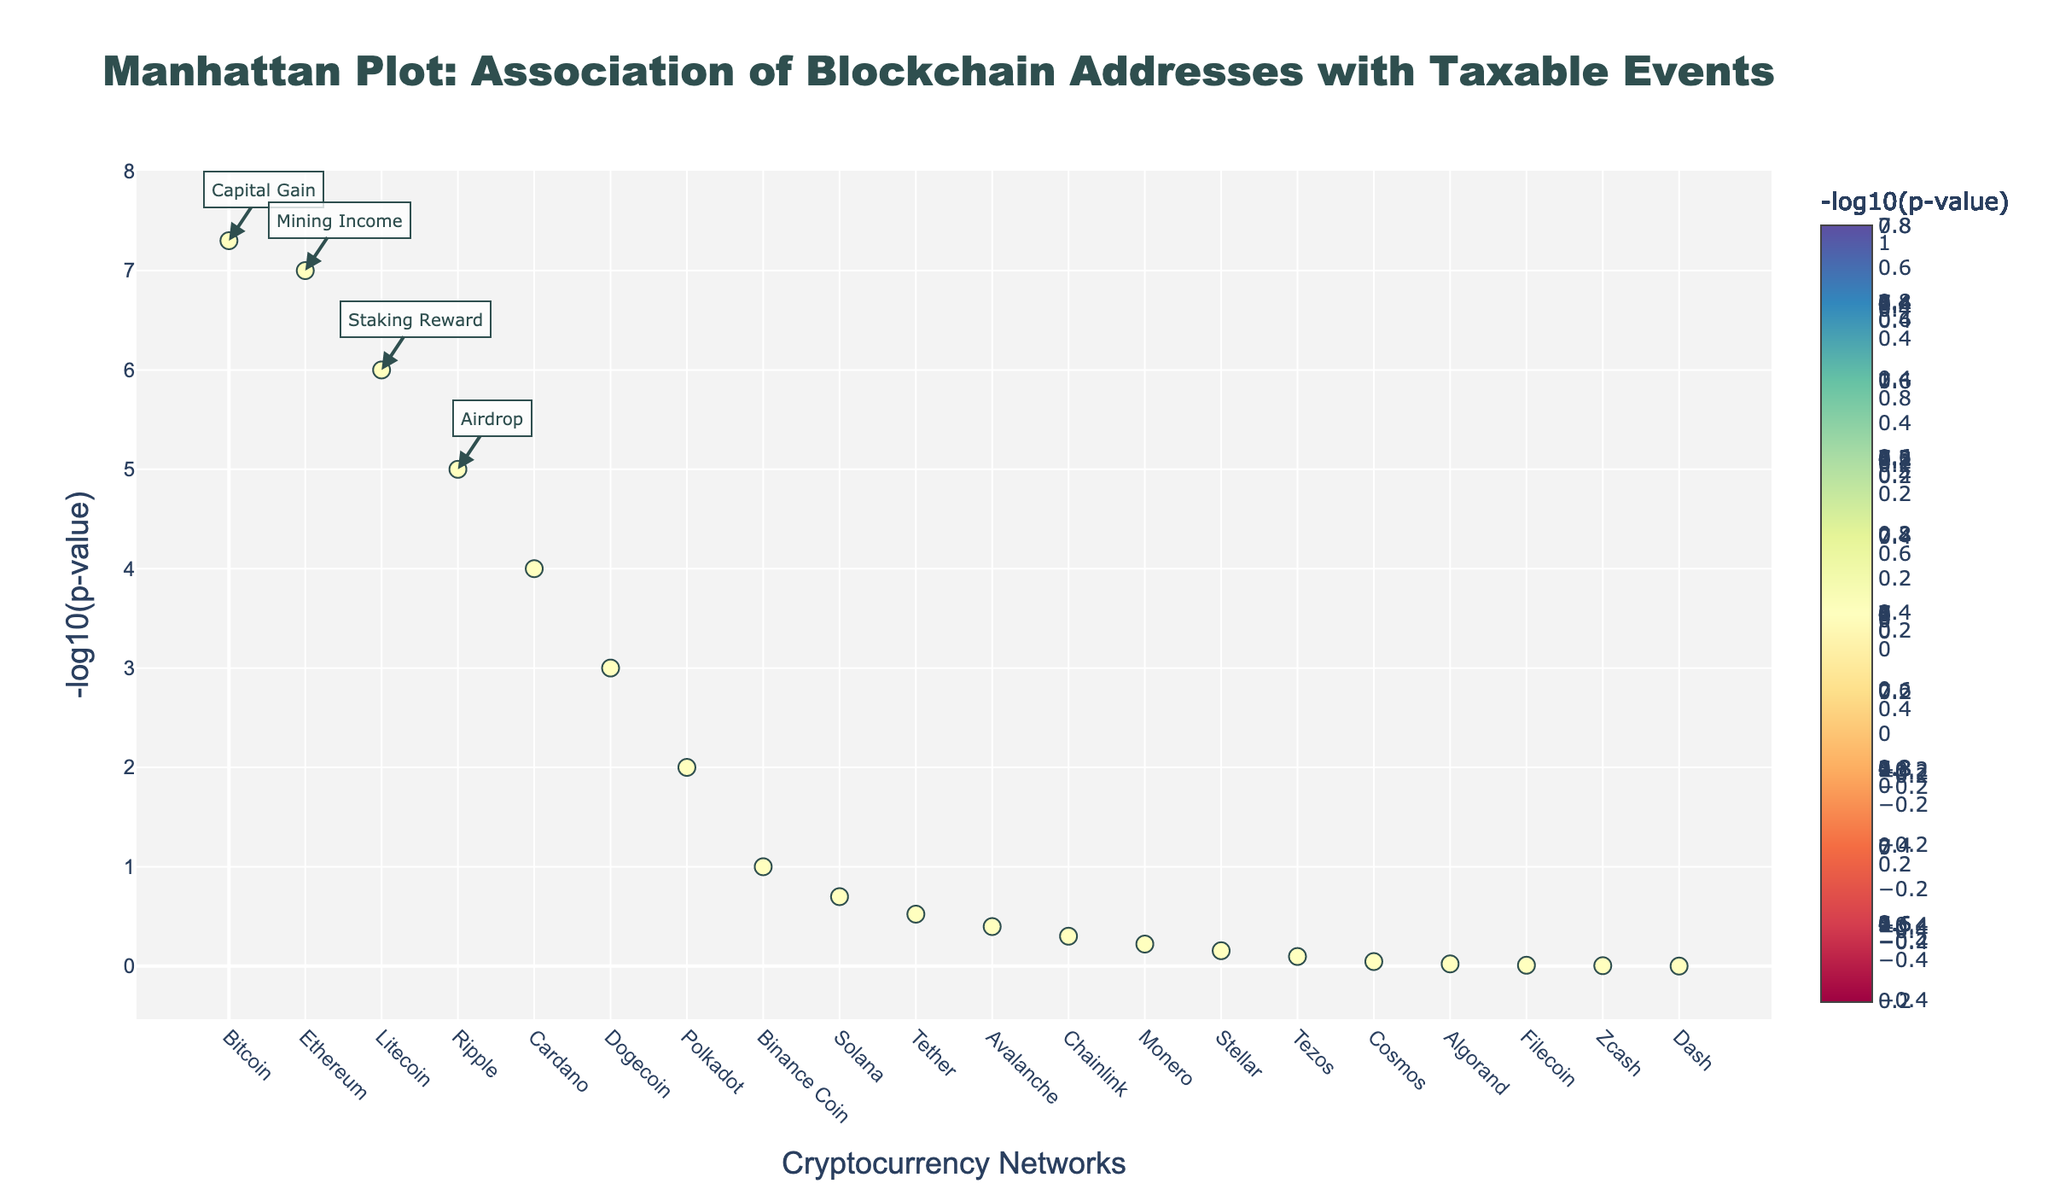What is the title of the plot? The title of the plot is prominently displayed at the top of the figure. It reads 'Manhattan Plot: Association of Blockchain Addresses with Taxable Events'.
Answer: Manhattan Plot: Association of Blockchain Addresses with Taxable Events Which cryptocurrency has the smallest p-value, and what taxable event does it correspond to? By observing the figure, the cryptocurrency with the smallest p-value is Bitcoin. It is located at the far left with the tallest bar, and the hover information indicates the corresponding taxable event is 'Capital Gain'.
Answer: Bitcoin, Capital Gain How many cryptocurrencies have a -log10(p-value) greater than 4? To determine this, we count the number of points above the y-value of 4 on the plot. Bitcoin and Ethereum surpass this threshold.
Answer: 2 What is the -log10(p-value) for Ripple? You can find this by locating Ripple on the x-axis and reading the corresponding y-value. The -log10(p-value) for Ripple is around 5.
Answer: 5 Compare the -log10(p-value) of Ethereum and Litecoin. Which is higher? Locate Ethereum and Litecoin on the x-axis. Ethereum’s -log10(p-value) is around 7, and Litecoin’s is around 6.
Answer: Ethereum Which taxable events have p-values between 0.0001 and 0.001? Find points that fall within the y-range (-log10(p-value)) of 3 to 4. These correspond to Litecoin and Cardano, with the taxable events 'Staking Reward' and 'NFT Sale' respectively.
Answer: Staking Reward, NFT Sale Which cryptocurrency has the lowest -log10(p-value), and what taxable event does it correspond to? The cryptocurrency with the lowest -log10(p-value) can be identified by finding the shortest bar. Dash, which is on the far right, has the lowest -log10(p-value), and the corresponding taxable event is 'Masternode Reward'.
Answer: Dash, Masternode Reward What is the approximate -log10(p-value) for Dogecoin, and what is the associated taxable event? Locate Dogecoin on the x-axis and read the y-value. Dogecoin appears to have a -log10(p-value) around 3, corresponding to 'Margin Trading'.
Answer: 3, Margin Trading How does the distribution of -log10(p-value) change as you move from Bitcoin to Dash? The -log10(p-value) generally decreases as you move from Bitcoin (furthest left) to Dash (furthest right), starting from a high value near 8 and dropping to near 0.
Answer: Generally decreases 